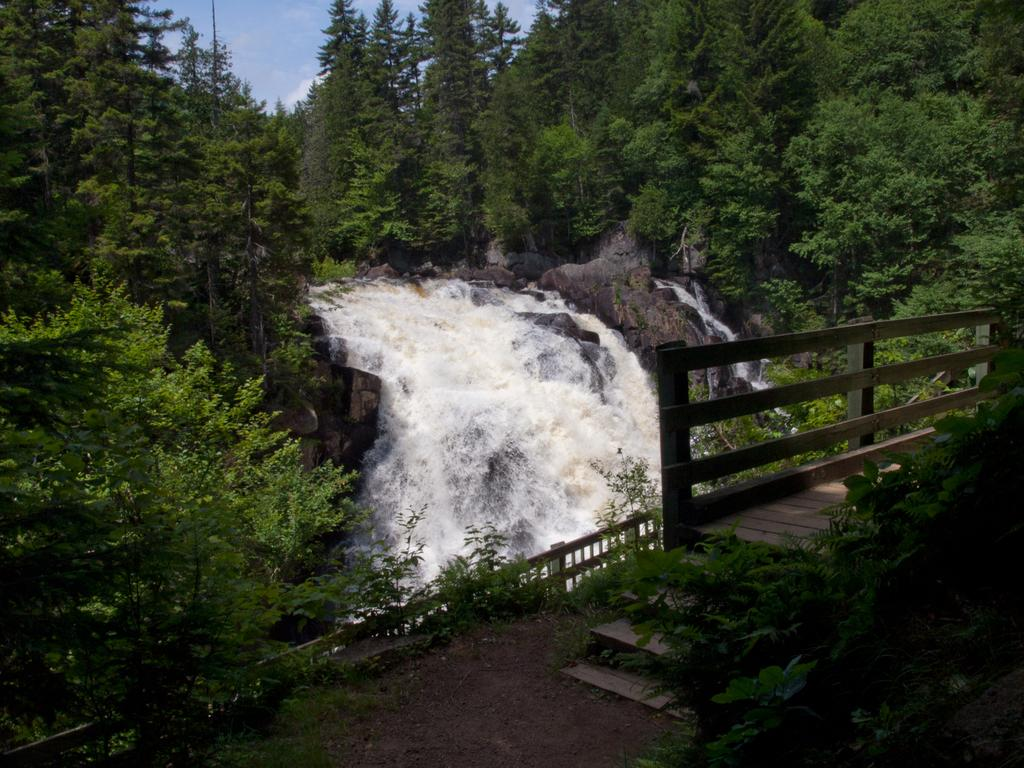What is the main feature in the center of the image? There is a waterfall in the center of the image. What can be seen in the background of the image? There are trees in the background of the image. What is located in the foreground of the image? There are stairs and a railing in the foreground of the image. What type of terrain is visible at the bottom of the image? There is sand at the bottom of the image. What is the tendency of the lift in the image? There is no lift present in the image. What nation is depicted in the image? The image does not depict a specific nation; it features a waterfall, trees, stairs, a railing, and sand. 